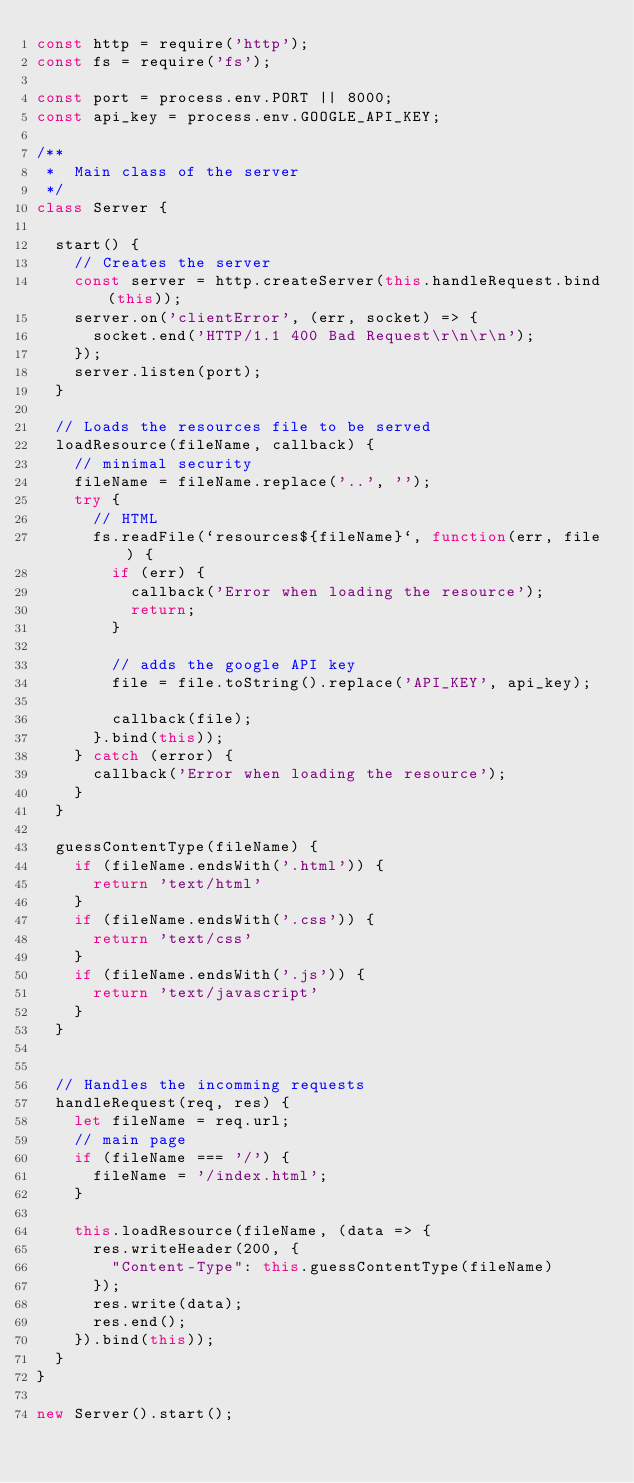Convert code to text. <code><loc_0><loc_0><loc_500><loc_500><_JavaScript_>const http = require('http');
const fs = require('fs');

const port = process.env.PORT || 8000;
const api_key = process.env.GOOGLE_API_KEY;

/**
 *  Main class of the server
 */
class Server {

  start() {
    // Creates the server
    const server = http.createServer(this.handleRequest.bind(this));
    server.on('clientError', (err, socket) => {
      socket.end('HTTP/1.1 400 Bad Request\r\n\r\n');
    });
    server.listen(port);
  }

  // Loads the resources file to be served
  loadResource(fileName, callback) {
    // minimal security
    fileName = fileName.replace('..', '');
    try {
      // HTML
      fs.readFile(`resources${fileName}`, function(err, file) {
        if (err) {
          callback('Error when loading the resource');
          return;
        }

        // adds the google API key
        file = file.toString().replace('API_KEY', api_key);

        callback(file);
      }.bind(this));
    } catch (error) {
      callback('Error when loading the resource');
    }
  }

  guessContentType(fileName) {
    if (fileName.endsWith('.html')) {
      return 'text/html'
    }
    if (fileName.endsWith('.css')) {
      return 'text/css'
    }
    if (fileName.endsWith('.js')) {
      return 'text/javascript'
    }
  }


  // Handles the incomming requests
  handleRequest(req, res) {
    let fileName = req.url;
    // main page
    if (fileName === '/') {
      fileName = '/index.html';
    }

    this.loadResource(fileName, (data => {
      res.writeHeader(200, {
        "Content-Type": this.guessContentType(fileName)
      });
      res.write(data);
      res.end();
    }).bind(this));
  }
}

new Server().start();
</code> 